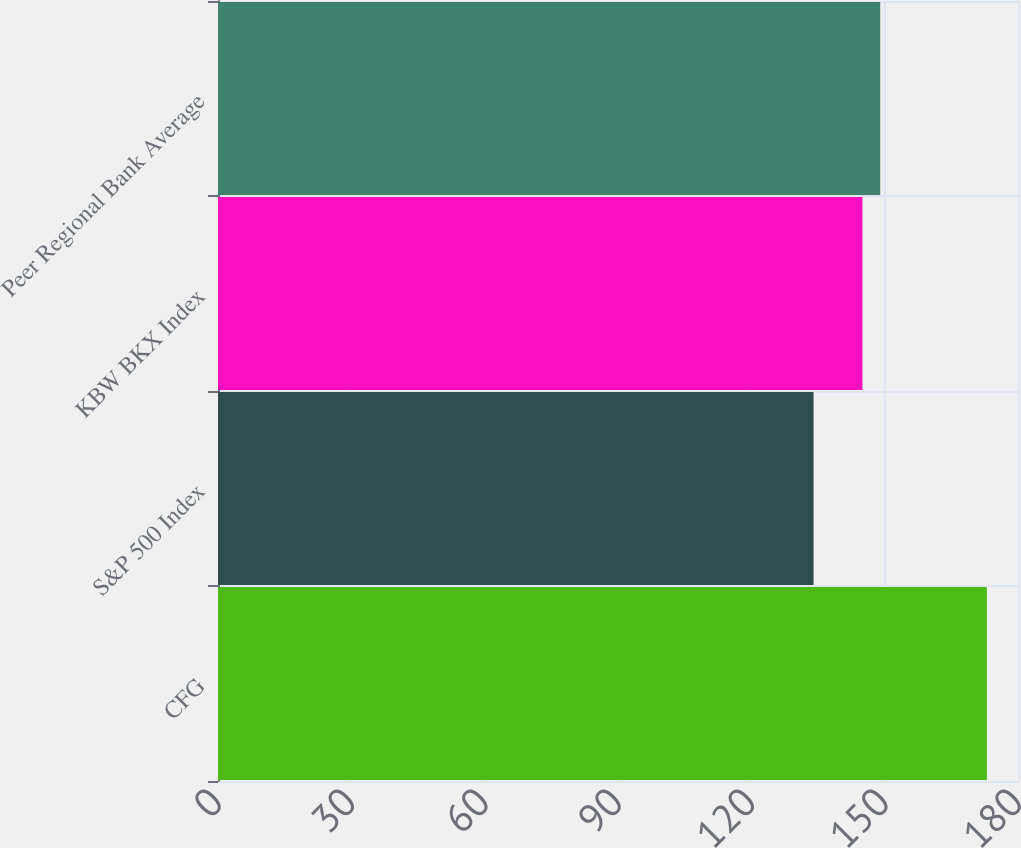<chart> <loc_0><loc_0><loc_500><loc_500><bar_chart><fcel>CFG<fcel>S&P 500 Index<fcel>KBW BKX Index<fcel>Peer Regional Bank Average<nl><fcel>173<fcel>134<fcel>145<fcel>149<nl></chart> 